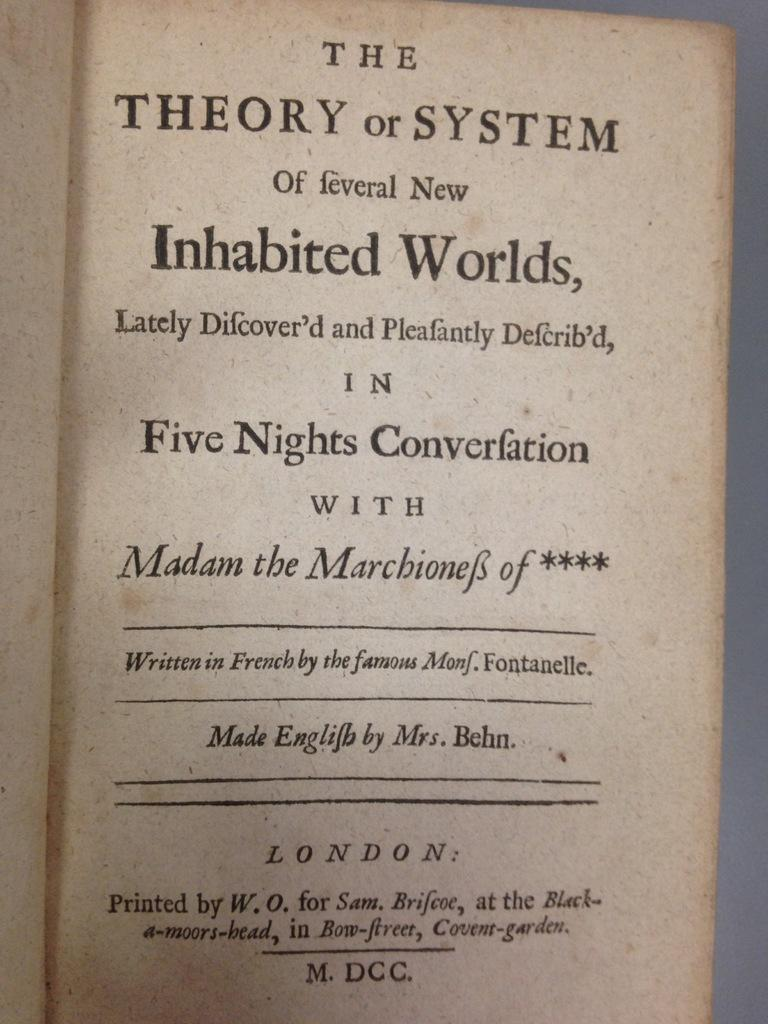<image>
Give a short and clear explanation of the subsequent image. A book on the Theory or System of Several New Inhabited Worlds is open to its title page. 